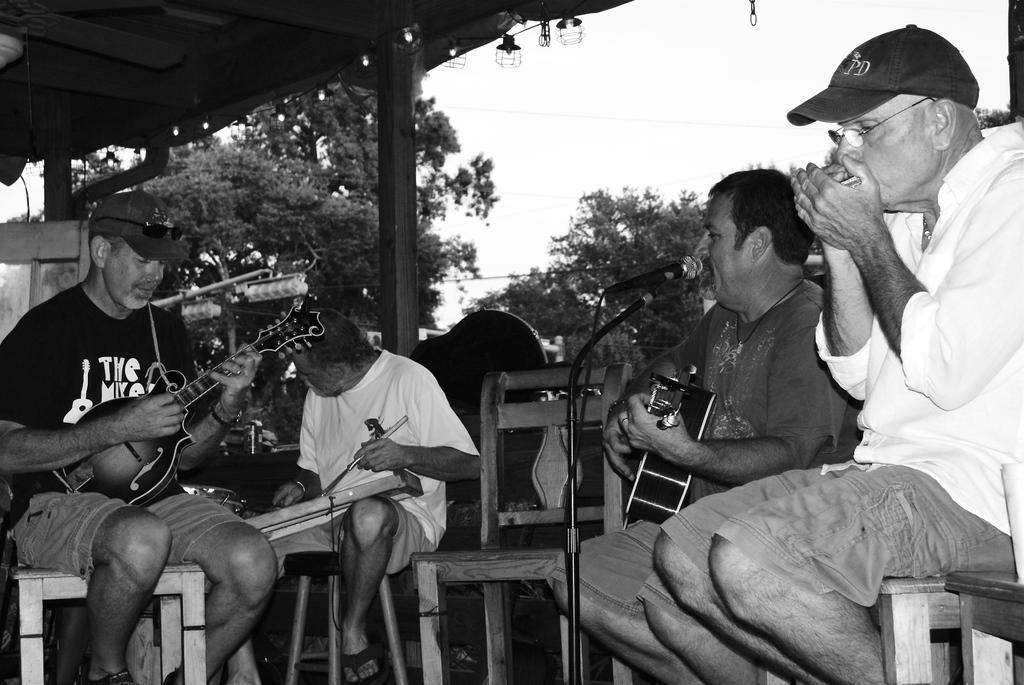Could you give a brief overview of what you see in this image? This is a black and white picture. There are four people who are sitting on a chair and performing the music and these people are holding some music instruments. This is a microphone. Background of this people is a tree and sky. 